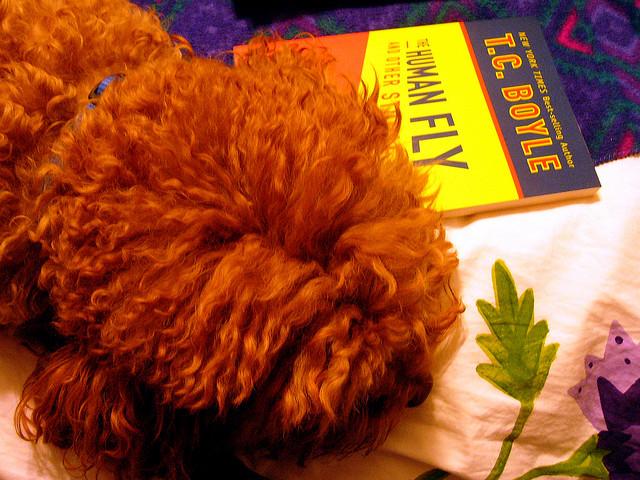What is the author's last name?
Answer briefly. Boyle. How many books are shown?
Write a very short answer. 1. What is the brown object?
Answer briefly. Dog. What color is the fur on the bear?
Answer briefly. Brown. Will eating these keep you healthy?
Concise answer only. No. 